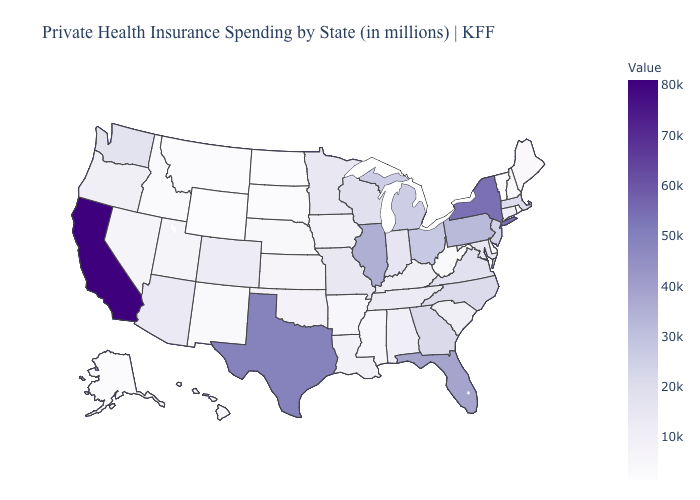Which states have the lowest value in the South?
Give a very brief answer. Delaware. Does California have the highest value in the USA?
Be succinct. Yes. Which states have the lowest value in the USA?
Quick response, please. Wyoming. 